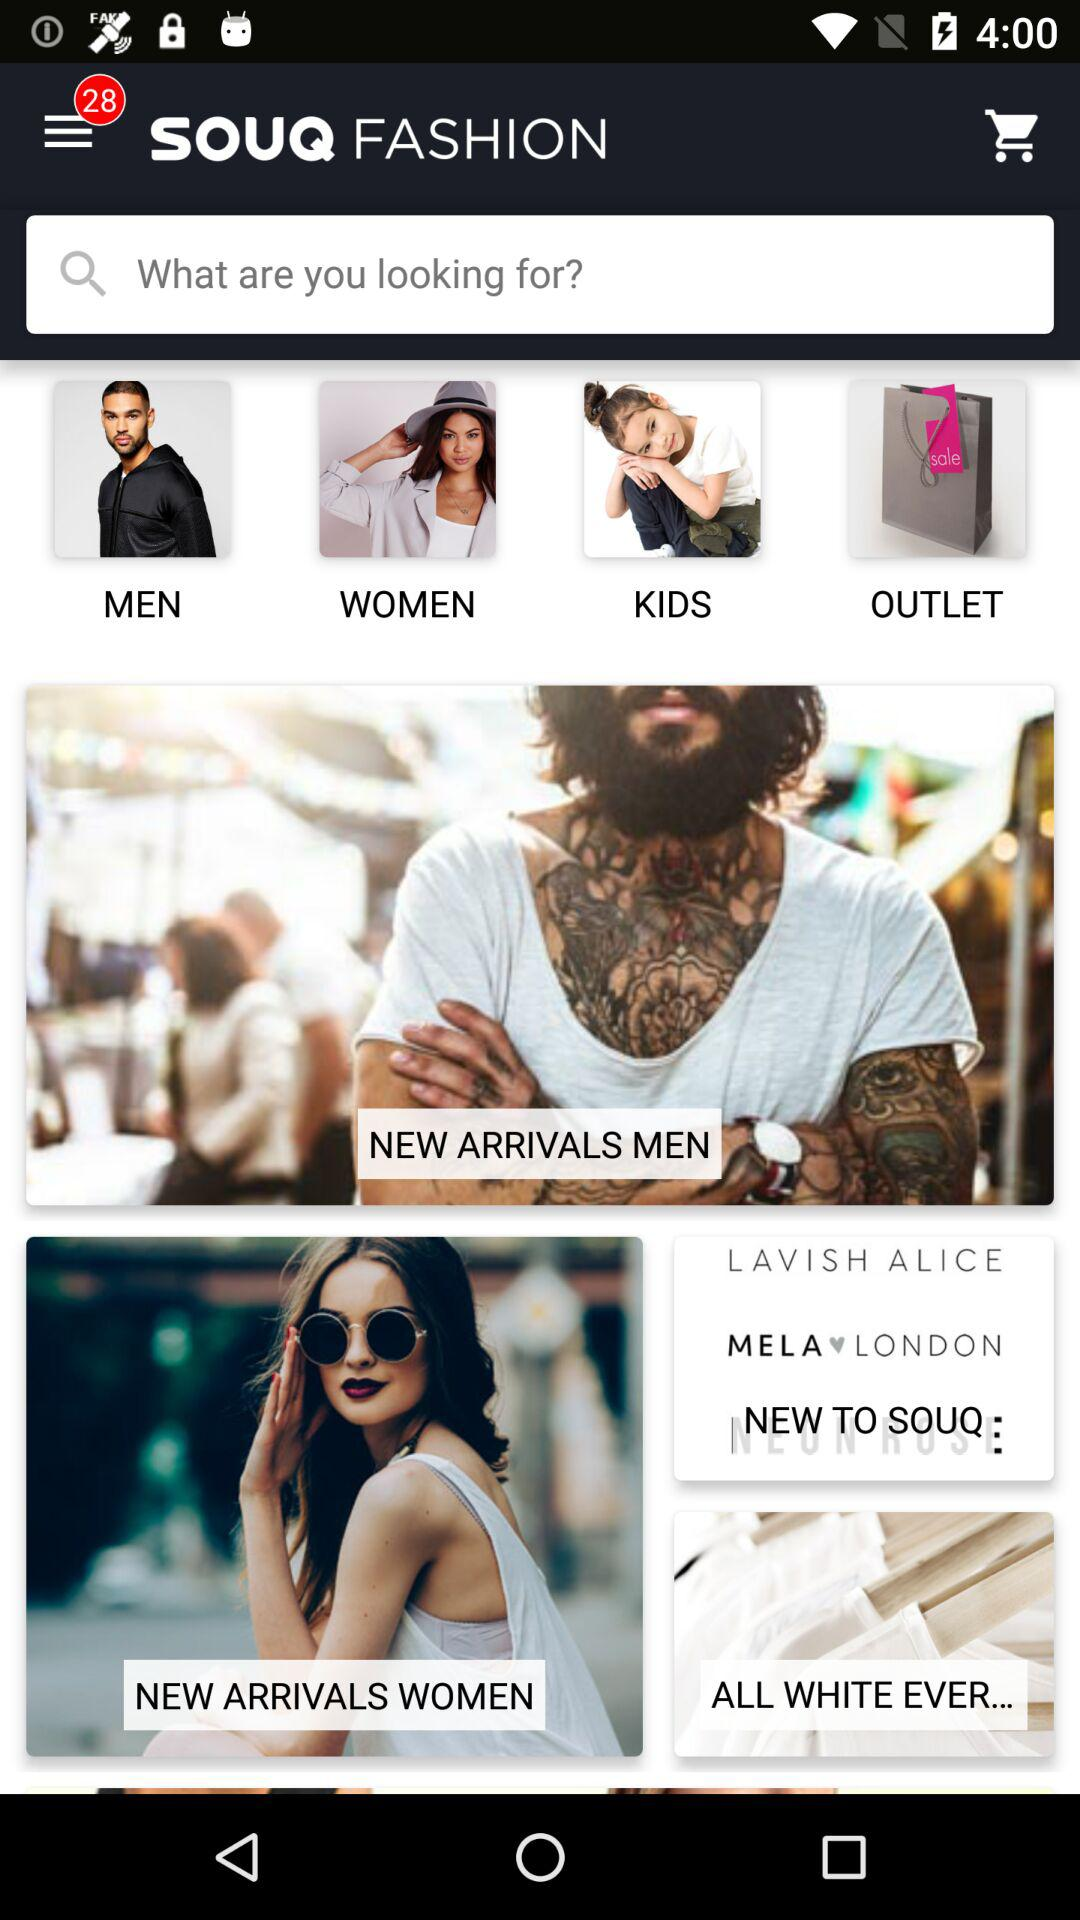Is there a "KIDS" option available? There is a "KIDS" option available. 